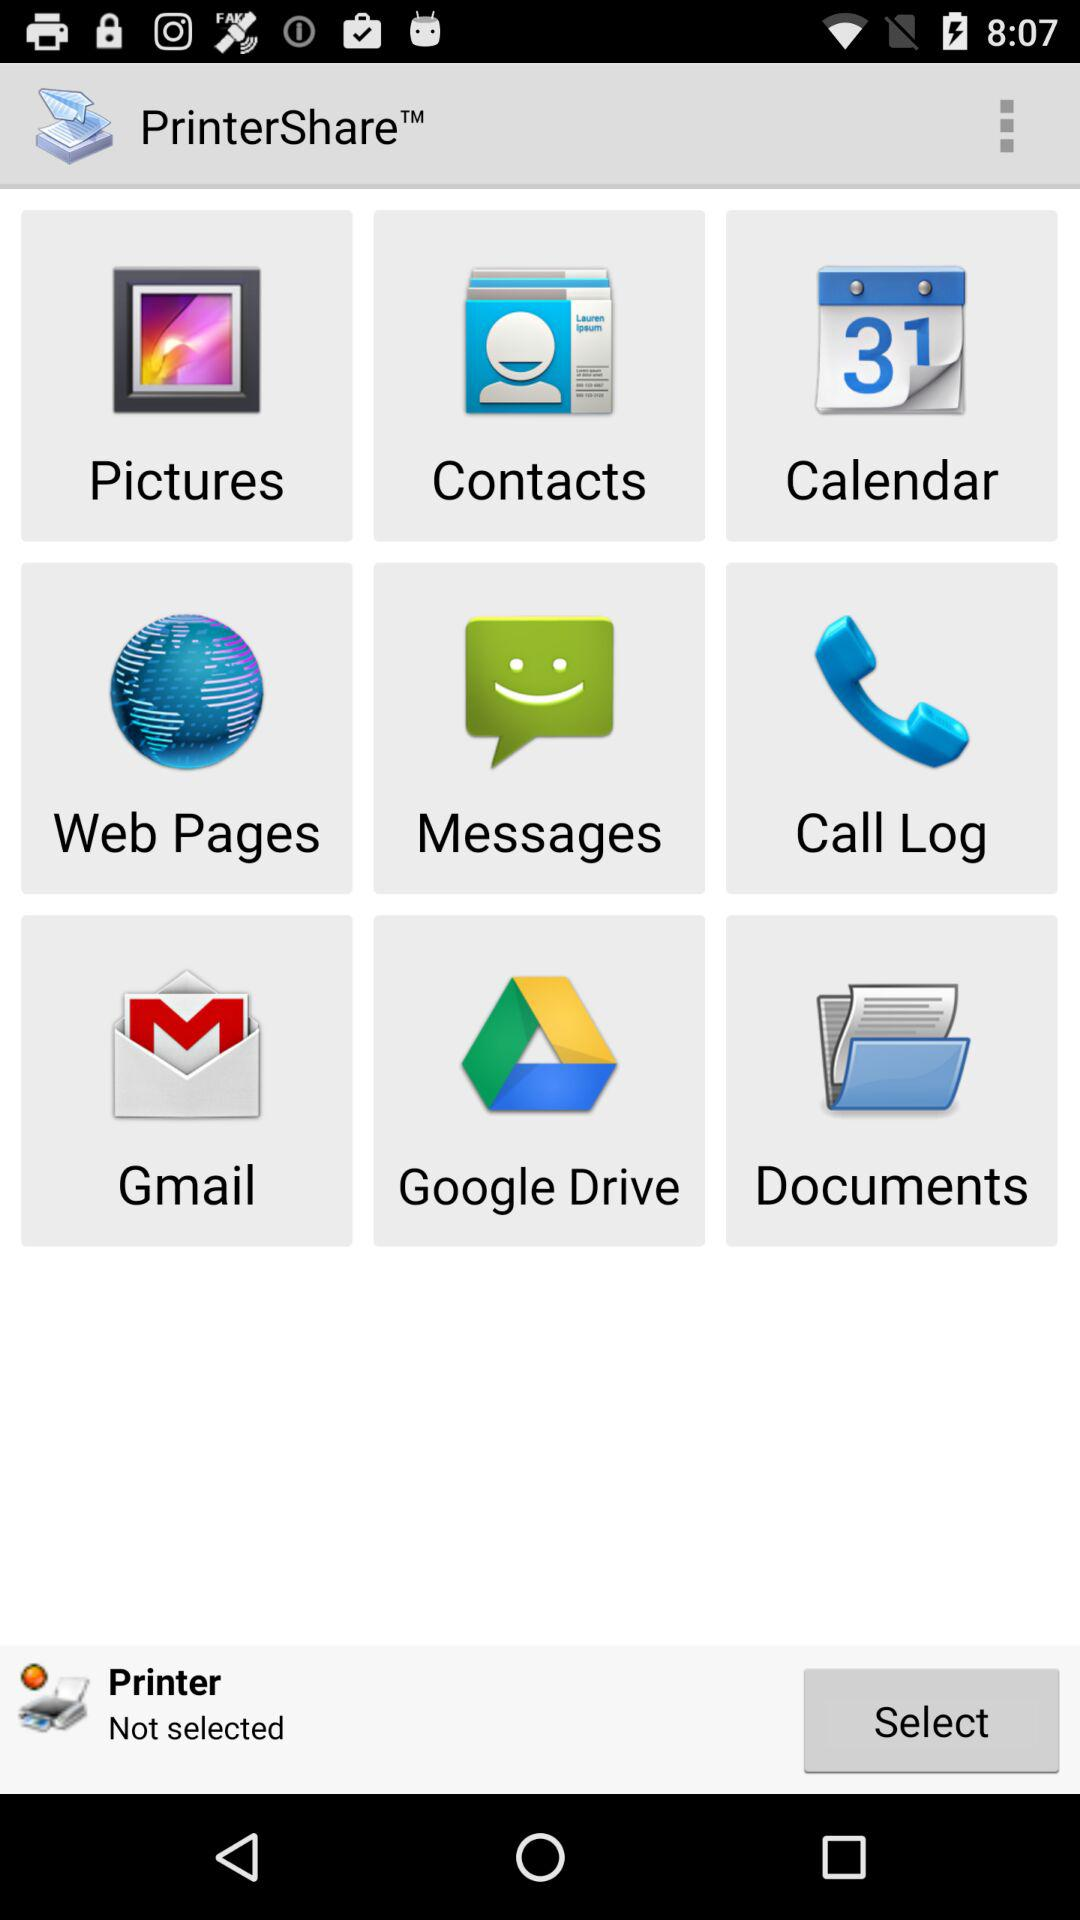Is the printer selected? The printer is not selected. 